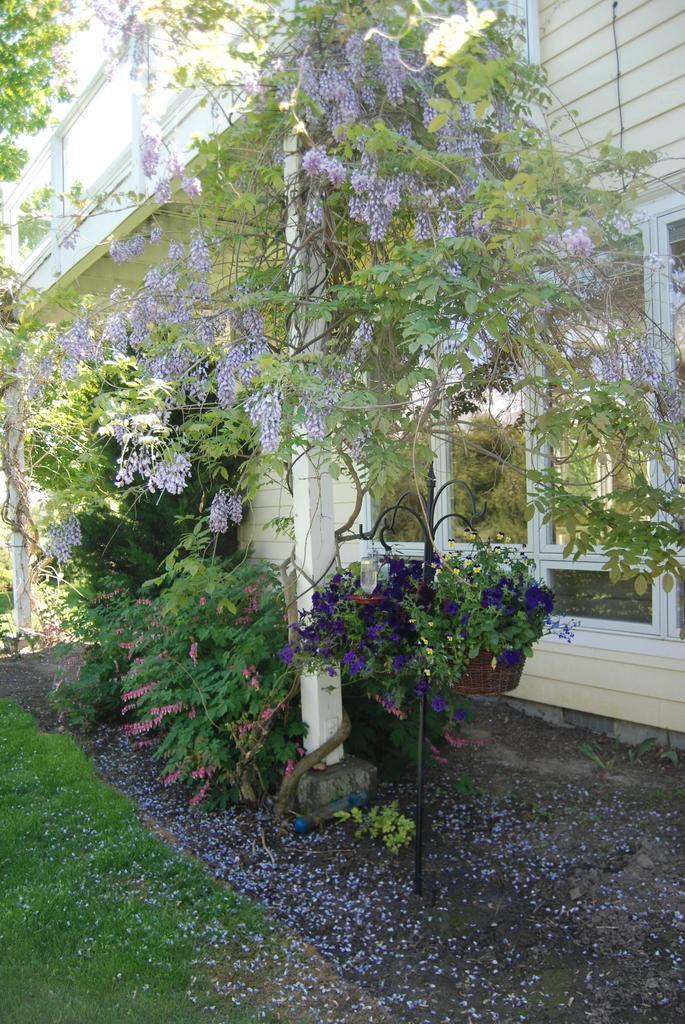How would you summarize this image in a sentence or two? On the ground there is grass. Also there are poles. Near to that there are many flowering plants. Also there is a pot with a plant and a stand. Near to that there is a building with windows. 